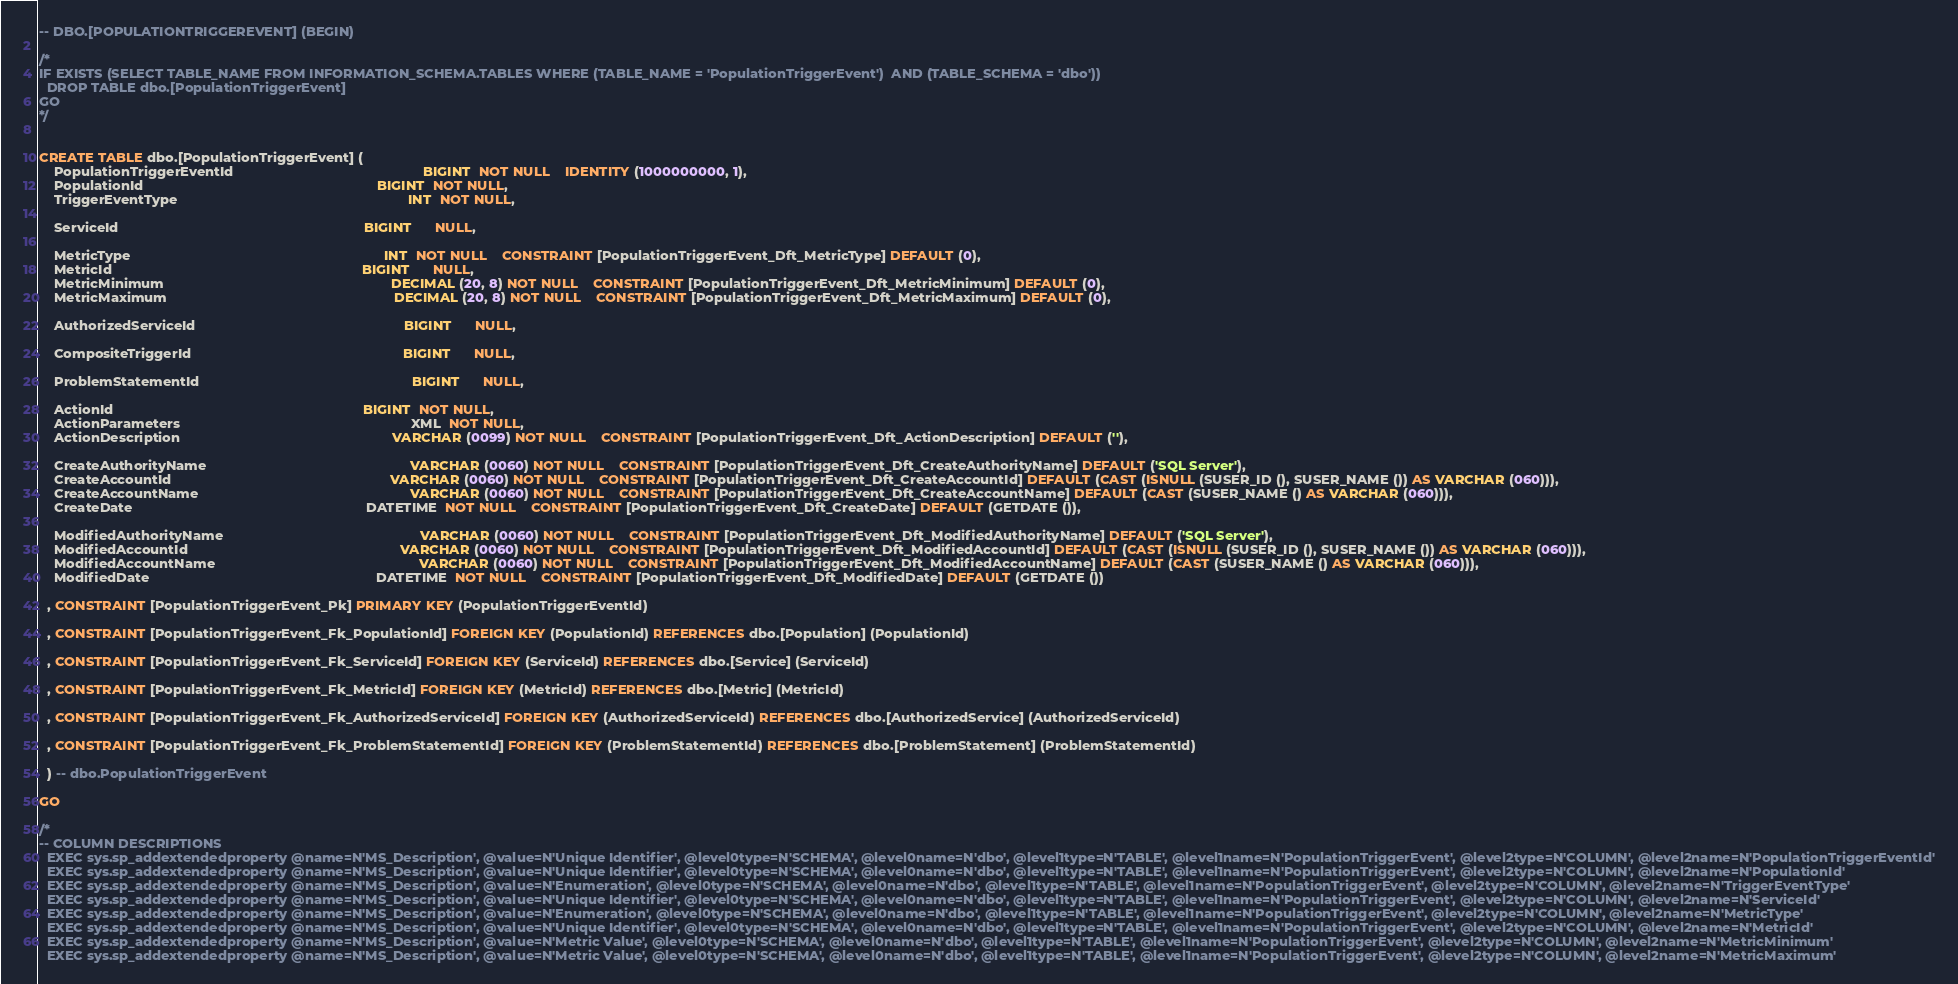<code> <loc_0><loc_0><loc_500><loc_500><_SQL_>-- DBO.[POPULATIONTRIGGEREVENT] (BEGIN) 

/* 
IF EXISTS (SELECT TABLE_NAME FROM INFORMATION_SCHEMA.TABLES WHERE (TABLE_NAME = 'PopulationTriggerEvent')  AND (TABLE_SCHEMA = 'dbo'))
  DROP TABLE dbo.[PopulationTriggerEvent]
GO 
*/ 


CREATE TABLE dbo.[PopulationTriggerEvent] (
    PopulationTriggerEventId                                                  BIGINT  NOT NULL    IDENTITY (1000000000, 1),
    PopulationId                                                              BIGINT  NOT NULL,
    TriggerEventType                                                             INT  NOT NULL,

    ServiceId                                                                 BIGINT      NULL,

    MetricType                                                                   INT  NOT NULL    CONSTRAINT [PopulationTriggerEvent_Dft_MetricType] DEFAULT (0),
    MetricId                                                                  BIGINT      NULL,
    MetricMinimum                                                            DECIMAL (20, 8) NOT NULL    CONSTRAINT [PopulationTriggerEvent_Dft_MetricMinimum] DEFAULT (0),
    MetricMaximum                                                            DECIMAL (20, 8) NOT NULL    CONSTRAINT [PopulationTriggerEvent_Dft_MetricMaximum] DEFAULT (0),

    AuthorizedServiceId                                                       BIGINT      NULL,

    CompositeTriggerId                                                        BIGINT      NULL,

    ProblemStatementId                                                        BIGINT      NULL,

    ActionId                                                                  BIGINT  NOT NULL,
    ActionParameters                                                             XML  NOT NULL,
    ActionDescription                                                        VARCHAR (0099) NOT NULL    CONSTRAINT [PopulationTriggerEvent_Dft_ActionDescription] DEFAULT (''),

    CreateAuthorityName                                                      VARCHAR (0060) NOT NULL    CONSTRAINT [PopulationTriggerEvent_Dft_CreateAuthorityName] DEFAULT ('SQL Server'),
    CreateAccountId                                                          VARCHAR (0060) NOT NULL    CONSTRAINT [PopulationTriggerEvent_Dft_CreateAccountId] DEFAULT (CAST (ISNULL (SUSER_ID (), SUSER_NAME ()) AS VARCHAR (060))),
    CreateAccountName                                                        VARCHAR (0060) NOT NULL    CONSTRAINT [PopulationTriggerEvent_Dft_CreateAccountName] DEFAULT (CAST (SUSER_NAME () AS VARCHAR (060))),
    CreateDate                                                              DATETIME  NOT NULL    CONSTRAINT [PopulationTriggerEvent_Dft_CreateDate] DEFAULT (GETDATE ()),

    ModifiedAuthorityName                                                    VARCHAR (0060) NOT NULL    CONSTRAINT [PopulationTriggerEvent_Dft_ModifiedAuthorityName] DEFAULT ('SQL Server'),
    ModifiedAccountId                                                        VARCHAR (0060) NOT NULL    CONSTRAINT [PopulationTriggerEvent_Dft_ModifiedAccountId] DEFAULT (CAST (ISNULL (SUSER_ID (), SUSER_NAME ()) AS VARCHAR (060))),
    ModifiedAccountName                                                      VARCHAR (0060) NOT NULL    CONSTRAINT [PopulationTriggerEvent_Dft_ModifiedAccountName] DEFAULT (CAST (SUSER_NAME () AS VARCHAR (060))),
    ModifiedDate                                                            DATETIME  NOT NULL    CONSTRAINT [PopulationTriggerEvent_Dft_ModifiedDate] DEFAULT (GETDATE ())

  , CONSTRAINT [PopulationTriggerEvent_Pk] PRIMARY KEY (PopulationTriggerEventId)

  , CONSTRAINT [PopulationTriggerEvent_Fk_PopulationId] FOREIGN KEY (PopulationId) REFERENCES dbo.[Population] (PopulationId)

  , CONSTRAINT [PopulationTriggerEvent_Fk_ServiceId] FOREIGN KEY (ServiceId) REFERENCES dbo.[Service] (ServiceId)

  , CONSTRAINT [PopulationTriggerEvent_Fk_MetricId] FOREIGN KEY (MetricId) REFERENCES dbo.[Metric] (MetricId)

  , CONSTRAINT [PopulationTriggerEvent_Fk_AuthorizedServiceId] FOREIGN KEY (AuthorizedServiceId) REFERENCES dbo.[AuthorizedService] (AuthorizedServiceId)

  , CONSTRAINT [PopulationTriggerEvent_Fk_ProblemStatementId] FOREIGN KEY (ProblemStatementId) REFERENCES dbo.[ProblemStatement] (ProblemStatementId)

  ) -- dbo.PopulationTriggerEvent

GO

/* 
-- COLUMN DESCRIPTIONS 
  EXEC sys.sp_addextendedproperty @name=N'MS_Description', @value=N'Unique Identifier', @level0type=N'SCHEMA', @level0name=N'dbo', @level1type=N'TABLE', @level1name=N'PopulationTriggerEvent', @level2type=N'COLUMN', @level2name=N'PopulationTriggerEventId'
  EXEC sys.sp_addextendedproperty @name=N'MS_Description', @value=N'Unique Identifier', @level0type=N'SCHEMA', @level0name=N'dbo', @level1type=N'TABLE', @level1name=N'PopulationTriggerEvent', @level2type=N'COLUMN', @level2name=N'PopulationId'
  EXEC sys.sp_addextendedproperty @name=N'MS_Description', @value=N'Enumeration', @level0type=N'SCHEMA', @level0name=N'dbo', @level1type=N'TABLE', @level1name=N'PopulationTriggerEvent', @level2type=N'COLUMN', @level2name=N'TriggerEventType'
  EXEC sys.sp_addextendedproperty @name=N'MS_Description', @value=N'Unique Identifier', @level0type=N'SCHEMA', @level0name=N'dbo', @level1type=N'TABLE', @level1name=N'PopulationTriggerEvent', @level2type=N'COLUMN', @level2name=N'ServiceId'
  EXEC sys.sp_addextendedproperty @name=N'MS_Description', @value=N'Enumeration', @level0type=N'SCHEMA', @level0name=N'dbo', @level1type=N'TABLE', @level1name=N'PopulationTriggerEvent', @level2type=N'COLUMN', @level2name=N'MetricType'
  EXEC sys.sp_addextendedproperty @name=N'MS_Description', @value=N'Unique Identifier', @level0type=N'SCHEMA', @level0name=N'dbo', @level1type=N'TABLE', @level1name=N'PopulationTriggerEvent', @level2type=N'COLUMN', @level2name=N'MetricId'
  EXEC sys.sp_addextendedproperty @name=N'MS_Description', @value=N'Metric Value', @level0type=N'SCHEMA', @level0name=N'dbo', @level1type=N'TABLE', @level1name=N'PopulationTriggerEvent', @level2type=N'COLUMN', @level2name=N'MetricMinimum'
  EXEC sys.sp_addextendedproperty @name=N'MS_Description', @value=N'Metric Value', @level0type=N'SCHEMA', @level0name=N'dbo', @level1type=N'TABLE', @level1name=N'PopulationTriggerEvent', @level2type=N'COLUMN', @level2name=N'MetricMaximum'</code> 